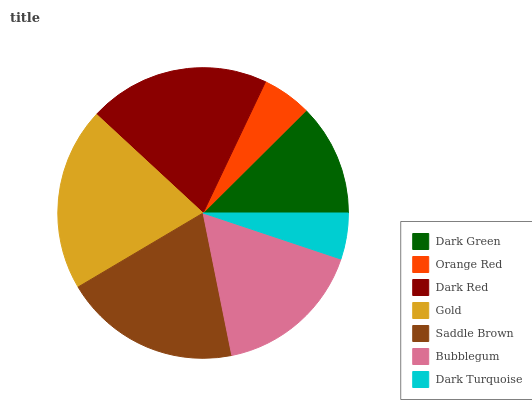Is Dark Turquoise the minimum?
Answer yes or no. Yes. Is Gold the maximum?
Answer yes or no. Yes. Is Orange Red the minimum?
Answer yes or no. No. Is Orange Red the maximum?
Answer yes or no. No. Is Dark Green greater than Orange Red?
Answer yes or no. Yes. Is Orange Red less than Dark Green?
Answer yes or no. Yes. Is Orange Red greater than Dark Green?
Answer yes or no. No. Is Dark Green less than Orange Red?
Answer yes or no. No. Is Bubblegum the high median?
Answer yes or no. Yes. Is Bubblegum the low median?
Answer yes or no. Yes. Is Dark Red the high median?
Answer yes or no. No. Is Gold the low median?
Answer yes or no. No. 